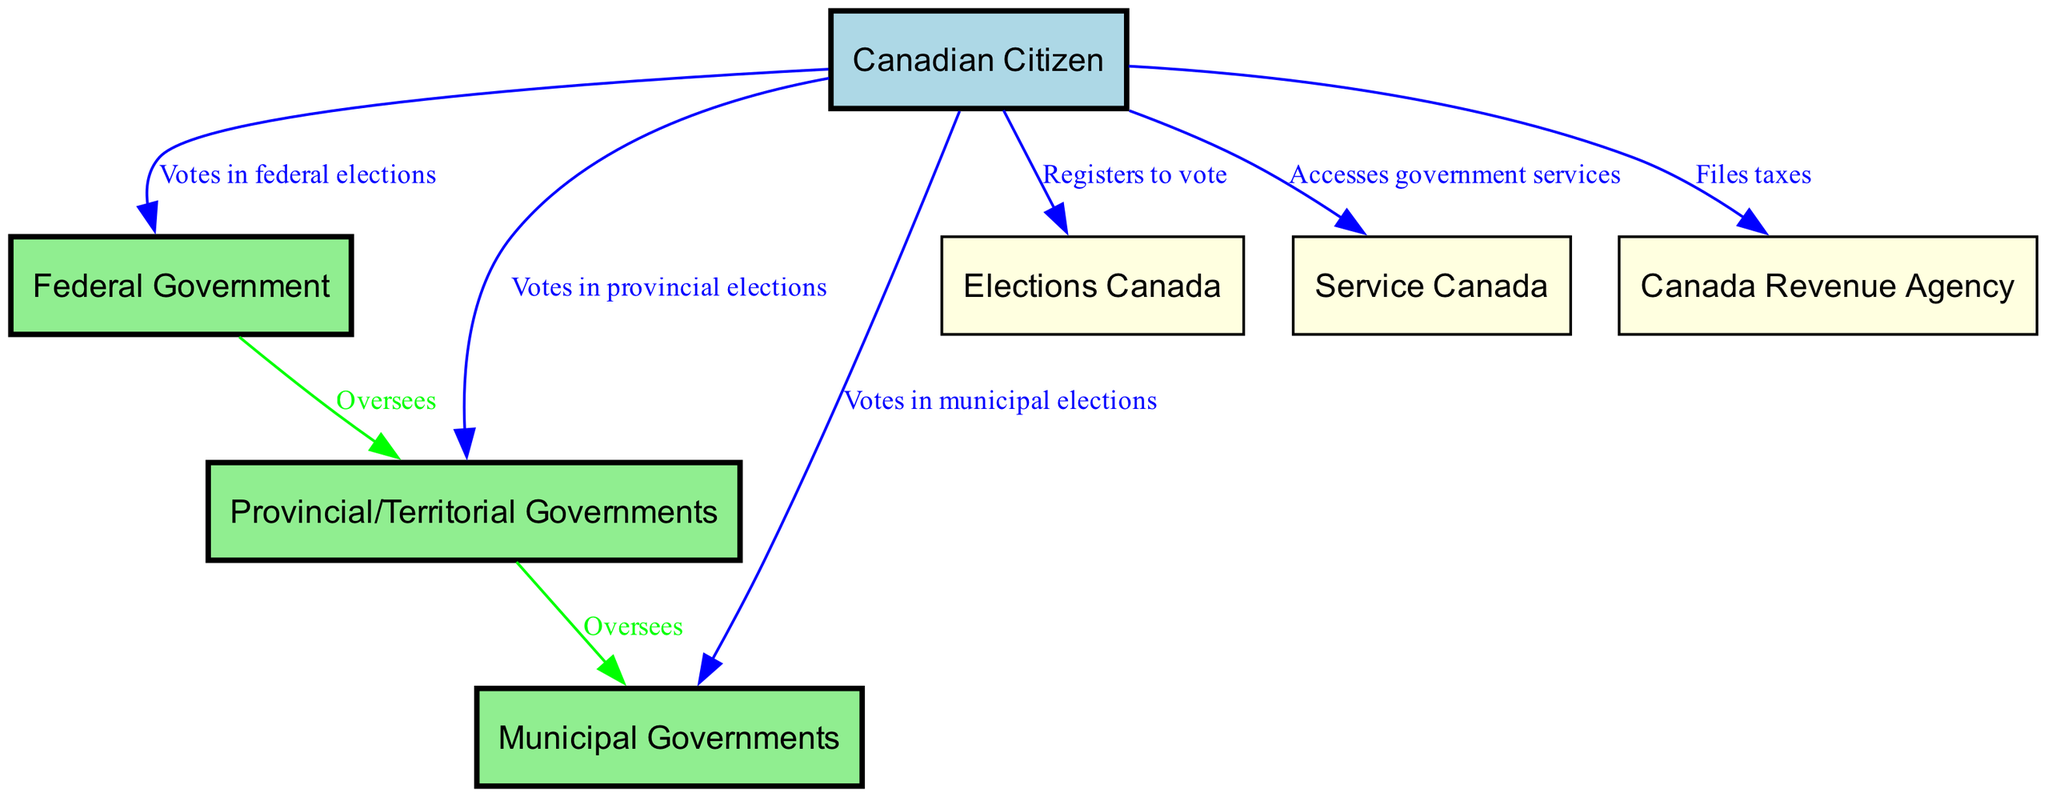What is the total number of nodes in the diagram? By counting the unique entities represented in the nodes list, we find that there are seven distinct nodes: Federal Government, Provincial/Territorial Governments, Municipal Governments, Canadian Citizen, Elections Canada, Service Canada, and Canada Revenue Agency.
Answer: 7 What action can Canadian citizens take regarding the federal government? The diagram indicates that Canadian citizens can vote in federal elections, explicitly shown by the edge connecting the citizen node to the federal government node with the label "Votes in federal elections."
Answer: Votes in federal elections Which government oversees the provincial governments? The relationship illustrated in the diagram shows that the federal government oversees the provincial governments, as indicated by the directed edge labeled "Oversees" connecting the federal node to the provincial node.
Answer: Federal Government What service can Canadian citizens access related to the municipal government? The diagram does not specify a direct edge for accessing services from the municipal government to the citizen; however, citizens can interact with municipal governments through the voting process during municipal elections, highlighted by the edge "Votes in municipal elections." However, it implies a broader access to services, not specifically illustrated in the edge relationships.
Answer: Votes in municipal elections Which organization should a Canadian citizen contact to register to vote? The diagram clearly illustrates that a Canadian citizen registers to vote through Elections Canada, as shown by the directed edge labeled "Registers to vote" connecting the citizen node to the Elections Canada node.
Answer: Elections Canada How many edges are present connecting the citizen node to other nodes? By analyzing the edges connected to the citizen node, there are six distinct edges leading from the citizen to federal, provincial, municipal, elections, services, and taxes, respectively.
Answer: 6 What is the main form of interaction between citizens and the Canada Revenue Agency? The interaction shown in the diagram is through filing taxes, as indicated by the edge labeled "Files taxes" connecting the citizen node to the Canada Revenue Agency node.
Answer: Files taxes Which level of government directly supervises the municipal governments? In the diagram, it is evident that the provincial governments oversee municipal governments, as represented by the directed edge labeled "Oversees" connecting the provincial node to the municipal node.
Answer: Provincial/Territorial Governments 